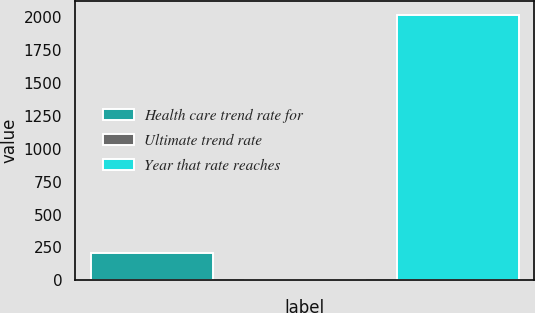<chart> <loc_0><loc_0><loc_500><loc_500><bar_chart><fcel>Health care trend rate for<fcel>Ultimate trend rate<fcel>Year that rate reaches<nl><fcel>206.5<fcel>5<fcel>2020<nl></chart> 